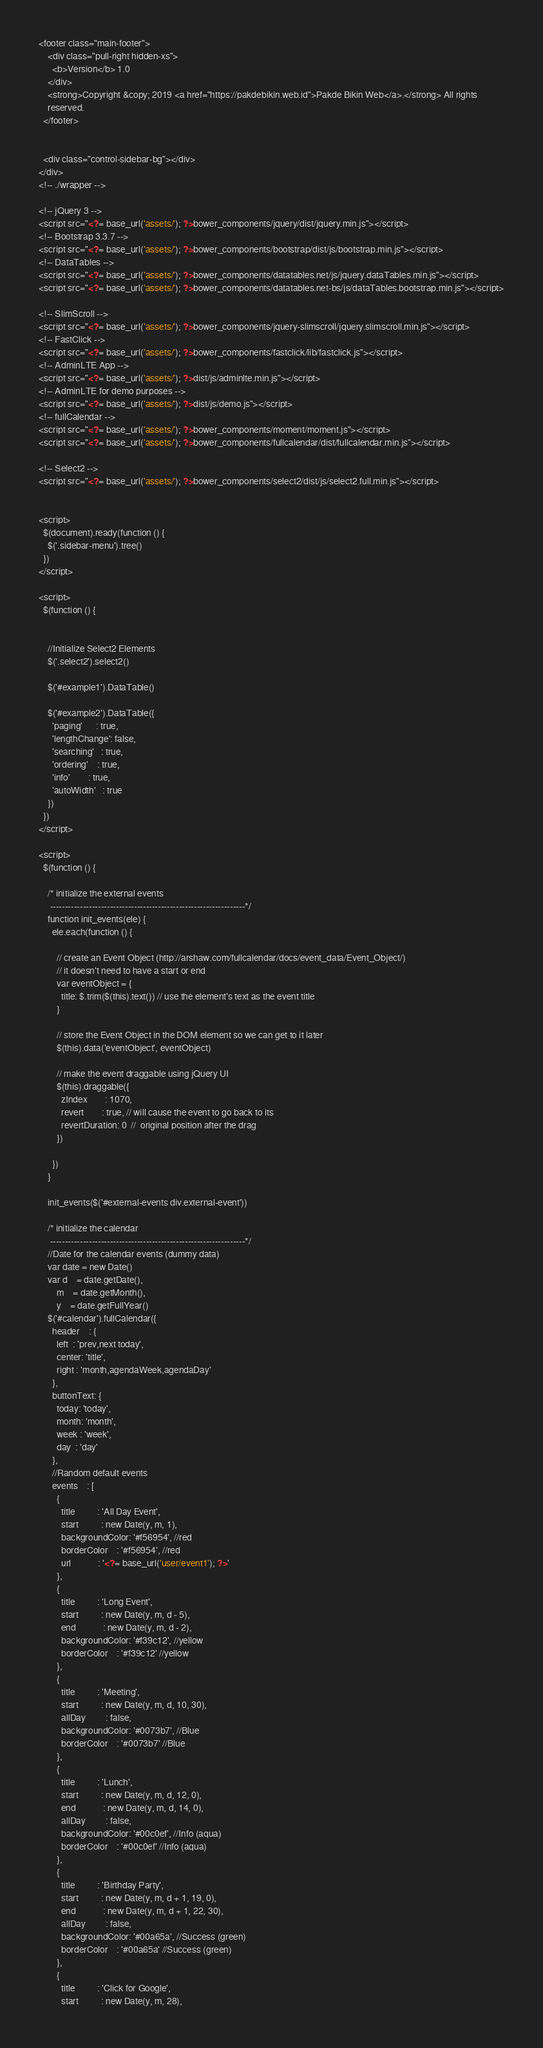<code> <loc_0><loc_0><loc_500><loc_500><_PHP_><footer class="main-footer">
    <div class="pull-right hidden-xs">
      <b>Version</b> 1.0
    </div>
    <strong>Copyright &copy; 2019 <a href="https://pakdebikin.web.id">Pakde Bikin Web</a>.</strong> All rights
    reserved.
  </footer>

  
  <div class="control-sidebar-bg"></div>
</div>
<!-- ./wrapper -->

<!-- jQuery 3 -->
<script src="<?= base_url('assets/'); ?>bower_components/jquery/dist/jquery.min.js"></script>
<!-- Bootstrap 3.3.7 -->
<script src="<?= base_url('assets/'); ?>bower_components/bootstrap/dist/js/bootstrap.min.js"></script>
<!-- DataTables -->
<script src="<?= base_url('assets/'); ?>bower_components/datatables.net/js/jquery.dataTables.min.js"></script>
<script src="<?= base_url('assets/'); ?>bower_components/datatables.net-bs/js/dataTables.bootstrap.min.js"></script>

<!-- SlimScroll -->
<script src="<?= base_url('assets/'); ?>bower_components/jquery-slimscroll/jquery.slimscroll.min.js"></script>
<!-- FastClick -->
<script src="<?= base_url('assets/'); ?>bower_components/fastclick/lib/fastclick.js"></script>
<!-- AdminLTE App -->
<script src="<?= base_url('assets/'); ?>dist/js/adminlte.min.js"></script>
<!-- AdminLTE for demo purposes -->
<script src="<?= base_url('assets/'); ?>dist/js/demo.js"></script>
<!-- fullCalendar -->
<script src="<?= base_url('assets/'); ?>bower_components/moment/moment.js"></script>
<script src="<?= base_url('assets/'); ?>bower_components/fullcalendar/dist/fullcalendar.min.js"></script>

<!-- Select2 -->
<script src="<?= base_url('assets/'); ?>bower_components/select2/dist/js/select2.full.min.js"></script>


<script>
  $(document).ready(function () {
    $('.sidebar-menu').tree()
  })
</script>

<script>
  $(function () {

    
    //Initialize Select2 Elements
    $('.select2').select2()
  
    $('#example1').DataTable()

    $('#example2').DataTable({
      'paging'      : true,
      'lengthChange': false,
      'searching'   : true,
      'ordering'    : true,
      'info'        : true,
      'autoWidth'   : true
    })
  })
</script>

<script>
  $(function () {

    /* initialize the external events
     -----------------------------------------------------------------*/
    function init_events(ele) {
      ele.each(function () {

        // create an Event Object (http://arshaw.com/fullcalendar/docs/event_data/Event_Object/)
        // it doesn't need to have a start or end
        var eventObject = {
          title: $.trim($(this).text()) // use the element's text as the event title
        }

        // store the Event Object in the DOM element so we can get to it later
        $(this).data('eventObject', eventObject)

        // make the event draggable using jQuery UI
        $(this).draggable({
          zIndex        : 1070,
          revert        : true, // will cause the event to go back to its
          revertDuration: 0  //  original position after the drag
        })

      })
    }

    init_events($('#external-events div.external-event'))

    /* initialize the calendar
     -----------------------------------------------------------------*/
    //Date for the calendar events (dummy data)
    var date = new Date()
    var d    = date.getDate(),
        m    = date.getMonth(),
        y    = date.getFullYear()
    $('#calendar').fullCalendar({
      header    : {
        left  : 'prev,next today',
        center: 'title',
        right : 'month,agendaWeek,agendaDay'
      },
      buttonText: {
        today: 'today',
        month: 'month',
        week : 'week',
        day  : 'day'
      },
      //Random default events
      events    : [
        {
          title          : 'All Day Event',
          start          : new Date(y, m, 1),
          backgroundColor: '#f56954', //red
          borderColor    : '#f56954', //red
          url            : '<?= base_url('user/event1'); ?>'
        },
        {
          title          : 'Long Event',
          start          : new Date(y, m, d - 5),
          end            : new Date(y, m, d - 2),
          backgroundColor: '#f39c12', //yellow
          borderColor    : '#f39c12' //yellow
        },
        {
          title          : 'Meeting',
          start          : new Date(y, m, d, 10, 30),
          allDay         : false,
          backgroundColor: '#0073b7', //Blue
          borderColor    : '#0073b7' //Blue
        },
        {
          title          : 'Lunch',
          start          : new Date(y, m, d, 12, 0),
          end            : new Date(y, m, d, 14, 0),
          allDay         : false,
          backgroundColor: '#00c0ef', //Info (aqua)
          borderColor    : '#00c0ef' //Info (aqua)
        },
        {
          title          : 'Birthday Party',
          start          : new Date(y, m, d + 1, 19, 0),
          end            : new Date(y, m, d + 1, 22, 30),
          allDay         : false,
          backgroundColor: '#00a65a', //Success (green)
          borderColor    : '#00a65a' //Success (green)
        },
        {
          title          : 'Click for Google',
          start          : new Date(y, m, 28),</code> 